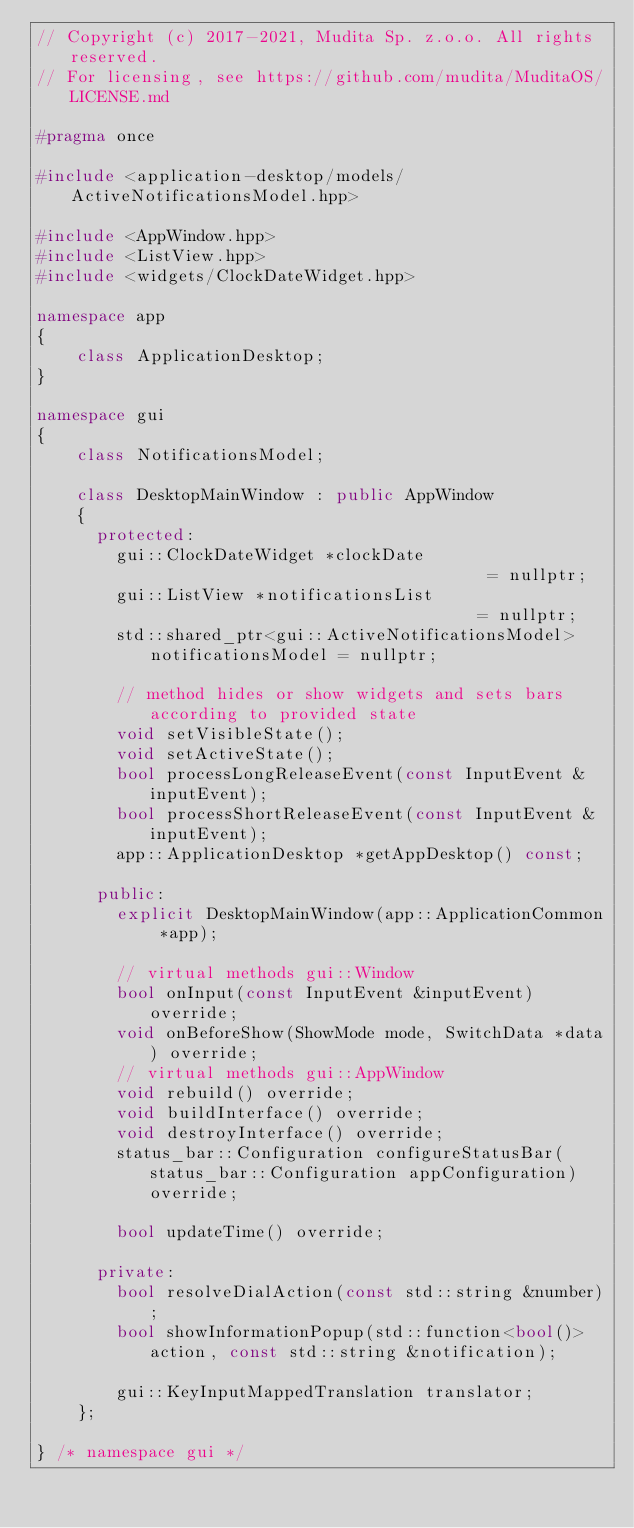<code> <loc_0><loc_0><loc_500><loc_500><_C++_>// Copyright (c) 2017-2021, Mudita Sp. z.o.o. All rights reserved.
// For licensing, see https://github.com/mudita/MuditaOS/LICENSE.md

#pragma once

#include <application-desktop/models/ActiveNotificationsModel.hpp>

#include <AppWindow.hpp>
#include <ListView.hpp>
#include <widgets/ClockDateWidget.hpp>

namespace app
{
    class ApplicationDesktop;
}

namespace gui
{
    class NotificationsModel;

    class DesktopMainWindow : public AppWindow
    {
      protected:
        gui::ClockDateWidget *clockDate                                   = nullptr;
        gui::ListView *notificationsList                                  = nullptr;
        std::shared_ptr<gui::ActiveNotificationsModel> notificationsModel = nullptr;

        // method hides or show widgets and sets bars according to provided state
        void setVisibleState();
        void setActiveState();
        bool processLongReleaseEvent(const InputEvent &inputEvent);
        bool processShortReleaseEvent(const InputEvent &inputEvent);
        app::ApplicationDesktop *getAppDesktop() const;

      public:
        explicit DesktopMainWindow(app::ApplicationCommon *app);

        // virtual methods gui::Window
        bool onInput(const InputEvent &inputEvent) override;
        void onBeforeShow(ShowMode mode, SwitchData *data) override;
        // virtual methods gui::AppWindow
        void rebuild() override;
        void buildInterface() override;
        void destroyInterface() override;
        status_bar::Configuration configureStatusBar(status_bar::Configuration appConfiguration) override;

        bool updateTime() override;

      private:
        bool resolveDialAction(const std::string &number);
        bool showInformationPopup(std::function<bool()> action, const std::string &notification);

        gui::KeyInputMappedTranslation translator;
    };

} /* namespace gui */
</code> 